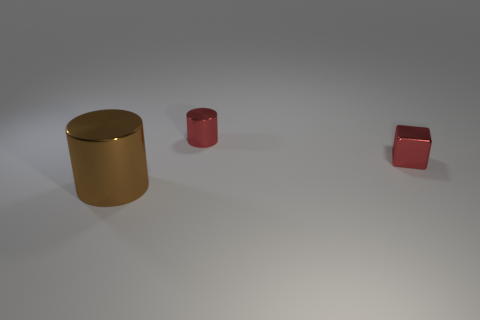Add 2 blue metallic spheres. How many objects exist? 5 Subtract all cylinders. How many objects are left? 1 Subtract all purple shiny things. Subtract all brown objects. How many objects are left? 2 Add 3 big brown things. How many big brown things are left? 4 Add 2 big gray cubes. How many big gray cubes exist? 2 Subtract 0 red spheres. How many objects are left? 3 